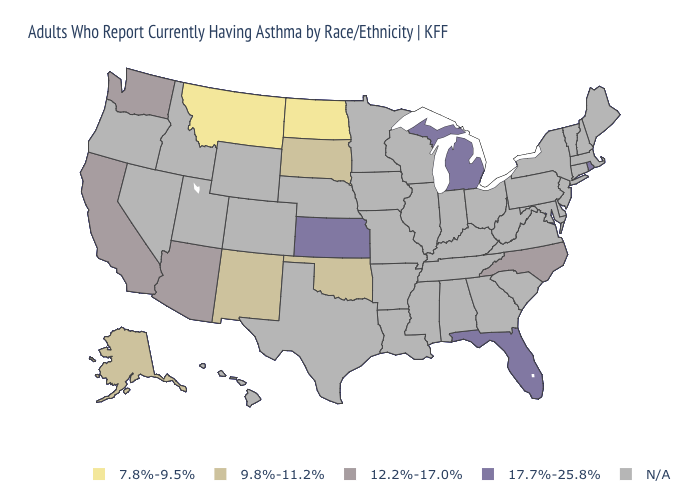What is the value of Georgia?
Quick response, please. N/A. What is the value of Ohio?
Give a very brief answer. N/A. What is the lowest value in the USA?
Be succinct. 7.8%-9.5%. What is the value of Michigan?
Answer briefly. 17.7%-25.8%. How many symbols are there in the legend?
Give a very brief answer. 5. What is the value of Montana?
Be succinct. 7.8%-9.5%. Does the map have missing data?
Give a very brief answer. Yes. How many symbols are there in the legend?
Write a very short answer. 5. Name the states that have a value in the range 9.8%-11.2%?
Write a very short answer. Alaska, New Mexico, Oklahoma, South Dakota. Name the states that have a value in the range 12.2%-17.0%?
Give a very brief answer. Arizona, California, North Carolina, Washington. Does the first symbol in the legend represent the smallest category?
Concise answer only. Yes. Does Washington have the lowest value in the USA?
Concise answer only. No. What is the value of Texas?
Concise answer only. N/A. 